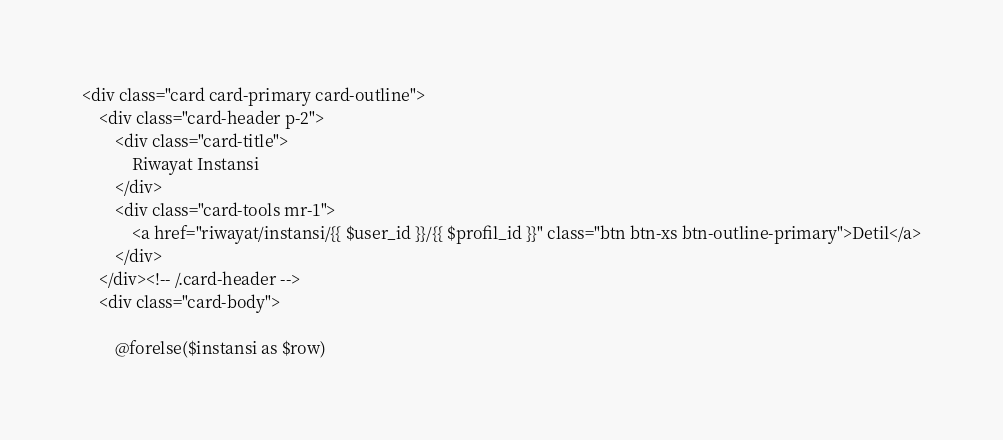Convert code to text. <code><loc_0><loc_0><loc_500><loc_500><_PHP_><div class="card card-primary card-outline">
    <div class="card-header p-2">
        <div class="card-title">
            Riwayat Instansi
        </div>
        <div class="card-tools mr-1">
            <a href="riwayat/instansi/{{ $user_id }}/{{ $profil_id }}" class="btn btn-xs btn-outline-primary">Detil</a>
        </div>
    </div><!-- /.card-header -->
    <div class="card-body">
        
        @forelse($instansi as $row)
</code> 